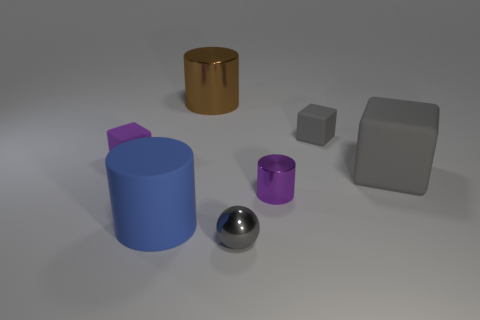Subtract all metal cylinders. How many cylinders are left? 1 Subtract 3 blocks. How many blocks are left? 0 Subtract all gray blocks. How many blocks are left? 1 Add 2 small gray things. How many objects exist? 9 Subtract 0 yellow cylinders. How many objects are left? 7 Subtract all spheres. How many objects are left? 6 Subtract all yellow spheres. Subtract all purple cylinders. How many spheres are left? 1 Subtract all purple balls. How many brown cylinders are left? 1 Subtract all tiny gray matte things. Subtract all small yellow rubber things. How many objects are left? 6 Add 2 brown cylinders. How many brown cylinders are left? 3 